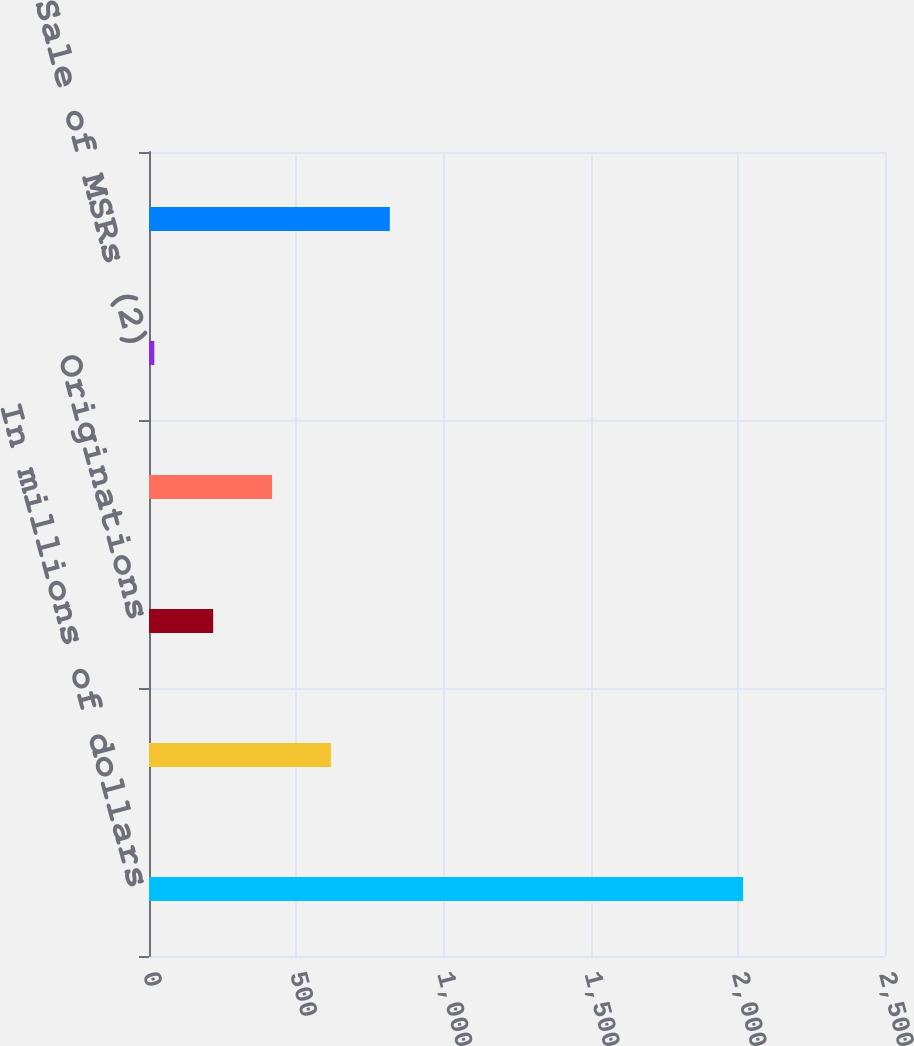<chart> <loc_0><loc_0><loc_500><loc_500><bar_chart><fcel>In millions of dollars<fcel>Balance beginning of year<fcel>Originations<fcel>Other changes (1)<fcel>Sale of MSRs (2)<fcel>Balance as of December 31<nl><fcel>2018<fcel>618<fcel>218<fcel>418<fcel>18<fcel>818<nl></chart> 